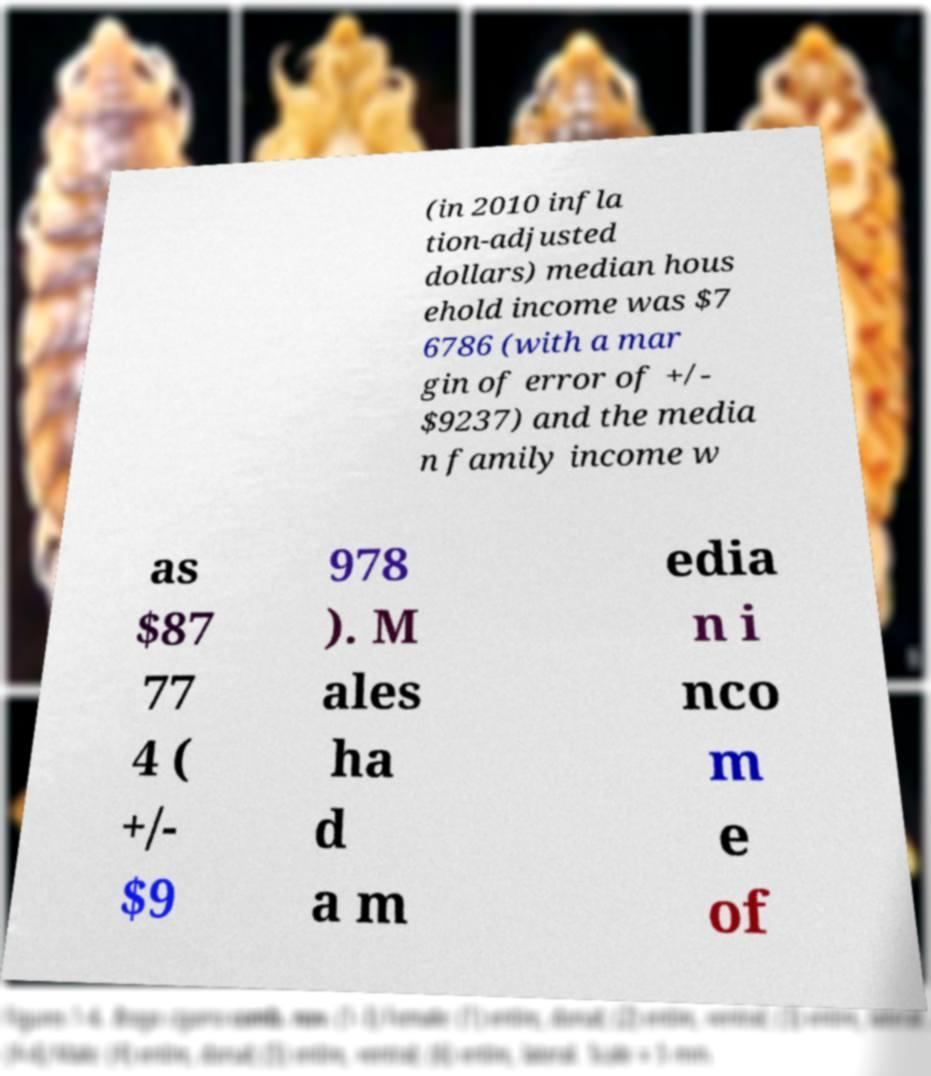Can you accurately transcribe the text from the provided image for me? (in 2010 infla tion-adjusted dollars) median hous ehold income was $7 6786 (with a mar gin of error of +/- $9237) and the media n family income w as $87 77 4 ( +/- $9 978 ). M ales ha d a m edia n i nco m e of 